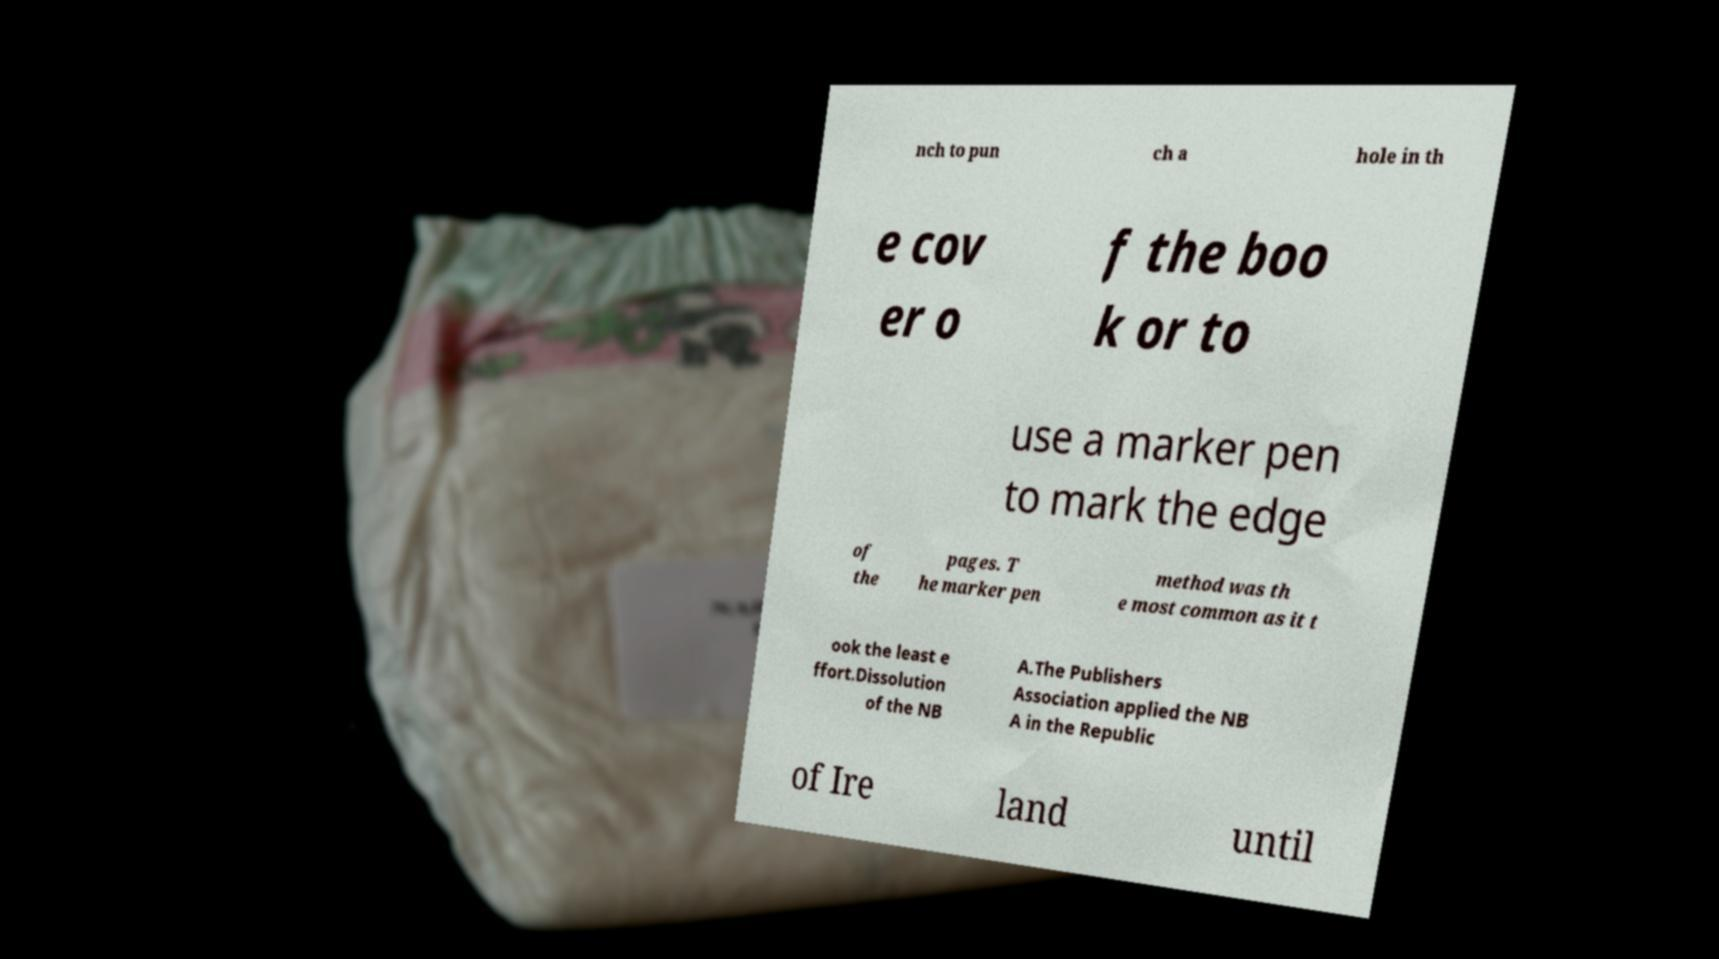Could you extract and type out the text from this image? nch to pun ch a hole in th e cov er o f the boo k or to use a marker pen to mark the edge of the pages. T he marker pen method was th e most common as it t ook the least e ffort.Dissolution of the NB A.The Publishers Association applied the NB A in the Republic of Ire land until 